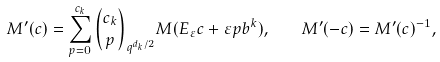Convert formula to latex. <formula><loc_0><loc_0><loc_500><loc_500>M ^ { \prime } ( c ) = \sum _ { p = 0 } ^ { c _ { k } } \binom { c _ { k } } { p } _ { q ^ { d _ { k } / 2 } } M ( E _ { \varepsilon } c + \varepsilon p b ^ { k } ) , \quad M ^ { \prime } ( - c ) = M ^ { \prime } ( c ) ^ { - 1 } ,</formula> 